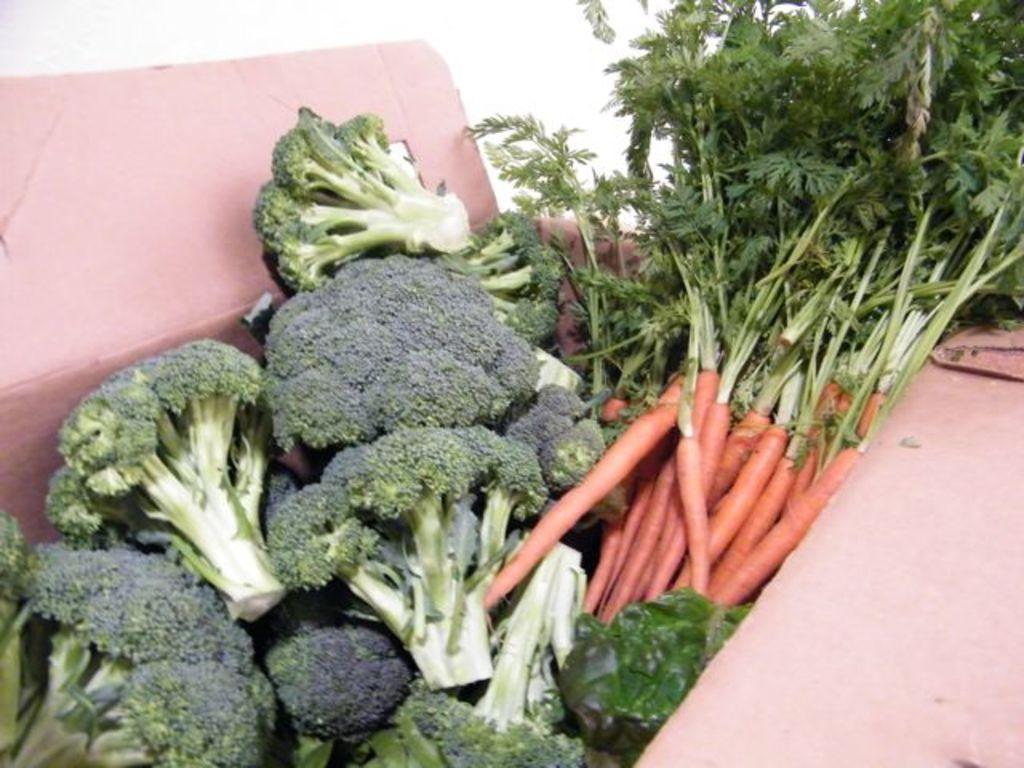What type of food can be seen in the image? There are raw vegetables in the image. How are the raw vegetables stored in the image? The raw vegetables are in a carton box. Where is the carton box located in the image? The carton box is in the center of the image. What type of boat is visible in the image? There is no boat present in the image. What language is being spoken by the vegetables in the image? Vegetables do not speak any language, and there is no indication of any language being spoken in the image. 